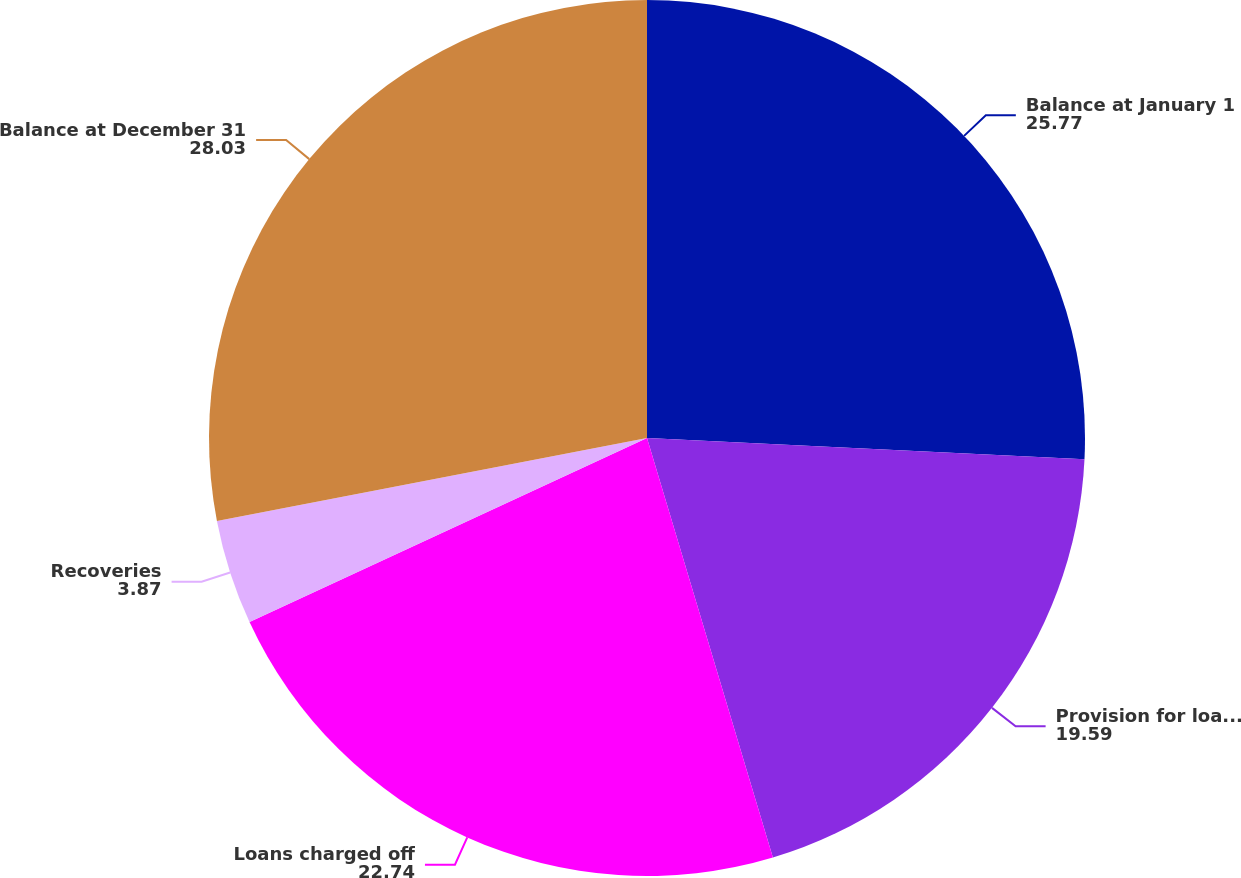<chart> <loc_0><loc_0><loc_500><loc_500><pie_chart><fcel>Balance at January 1<fcel>Provision for loan losses<fcel>Loans charged off<fcel>Recoveries<fcel>Balance at December 31<nl><fcel>25.77%<fcel>19.59%<fcel>22.74%<fcel>3.87%<fcel>28.03%<nl></chart> 